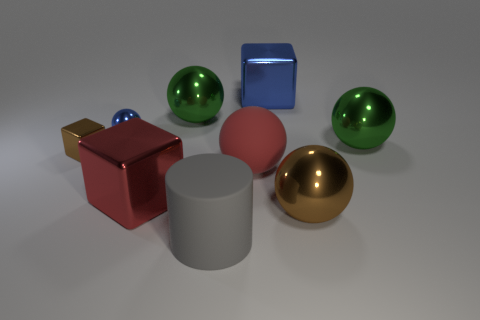How many green spheres must be subtracted to get 1 green spheres? 1 Subtract all tiny balls. How many balls are left? 4 Subtract all red balls. How many balls are left? 4 Subtract all cyan balls. Subtract all green cylinders. How many balls are left? 5 Subtract all cylinders. How many objects are left? 8 Subtract all small purple objects. Subtract all brown metal cubes. How many objects are left? 8 Add 5 red balls. How many red balls are left? 6 Add 7 yellow metal blocks. How many yellow metal blocks exist? 7 Subtract 0 brown cylinders. How many objects are left? 9 